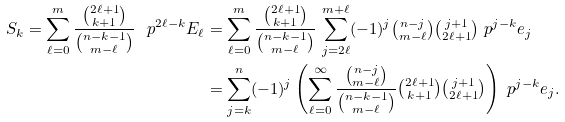Convert formula to latex. <formula><loc_0><loc_0><loc_500><loc_500>S _ { k } = \sum _ { \ell = 0 } ^ { m } \frac { \binom { 2 \ell + 1 } { k + 1 } } { \binom { n - k - 1 } { m - \ell } } \, \ p ^ { 2 \ell - k } E _ { \ell } & = \sum _ { \ell = 0 } ^ { m } \frac { \binom { 2 \ell + 1 } { k + 1 } } { \binom { n - k - 1 } { m - \ell } } \, \sum _ { j = 2 \ell } ^ { m + \ell } ( - 1 ) ^ { j } \tbinom { n - j } { m - \ell } \tbinom { j + 1 } { 2 \ell + 1 } \ p ^ { j - k } e _ { j } \\ & = \sum _ { j = k } ^ { n } ( - 1 ) ^ { j } \left ( \sum _ { \ell = 0 } ^ { \infty } \frac { \tbinom { n - j } { m - \ell } } { \binom { n - k - 1 } { m - \ell } } \tbinom { 2 \ell + 1 } { k + 1 } \tbinom { j + 1 } { 2 \ell + 1 } \right ) \ p ^ { j - k } e _ { j } .</formula> 